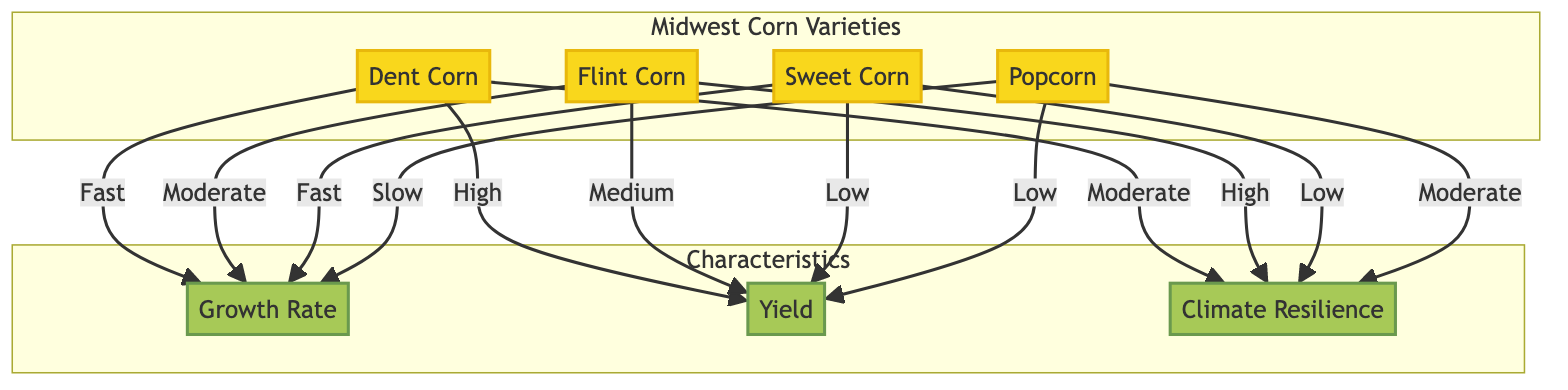What type of corn has the highest yield? By examining the yield characteristics of each corn variety in the diagram, it is clear that Dent Corn has the highest yield categorized as "High."
Answer: High Which corn type grows the fastest? The growth rate characteristics indicate that both Dent Corn and Sweet Corn have a "Fast" growth rate, but the question asks for the one with the highest growth rate. Thus, Dent Corn is notable for being one of them and often considered faster among typical comparisons.
Answer: Fast How many corn varieties are compared in the diagram? The diagram displays four distinct types of corn: Dent Corn, Flint Corn, Sweet Corn, and Popcorn. Counting these varieties gives the total number presented in the diagram.
Answer: Four Which corn variety has the lowest climate resilience? Upon reviewing the climate resilience aspects of the corn types, Sweet Corn and Popcorn both show "Low" resilience, but the question focuses on identifying one. Since the other varieties have a higher resilience classification, Sweet Corn is noted for its low resilience.
Answer: Low What is the growth rate of Flint Corn? The diagram states that Flint Corn has a "Moderate" growth rate, which can be found directly in its corresponding characteristic.
Answer: Moderate Which corn type has a low yield alongside low climate resilience? Sweet Corn is the only type in the diagram that is labeled as both having a "Low" yield and "Low" climate resilience, making it the answer to this query regarding the correlation between these two characteristics.
Answer: Low What characteristic of Popcorn is rated as "Moderate"? By looking at the specified characteristics of Popcorn in the diagram, it is indicated that climate resilience is rated as "Moderate," thus answering the question based on direct information given.
Answer: Moderate Which corn has a medium yield? Flint Corn is identified in the diagram as having a "Medium" yield, distinguishing it from the other varieties in terms of its production capability.
Answer: Medium What type of corn has the slowest growth rate? The diagram categorizes Popcorn with a "Slow" growth rate, which directly points to it being the corn type with the slowest growth in comparison to the others.
Answer: Slow 